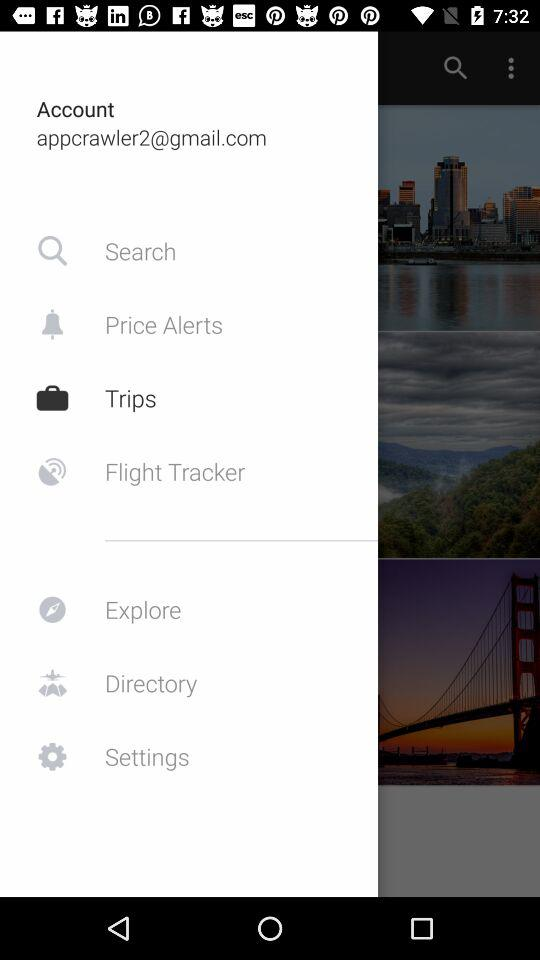Which tab is selected? The selected tab is "Trips". 